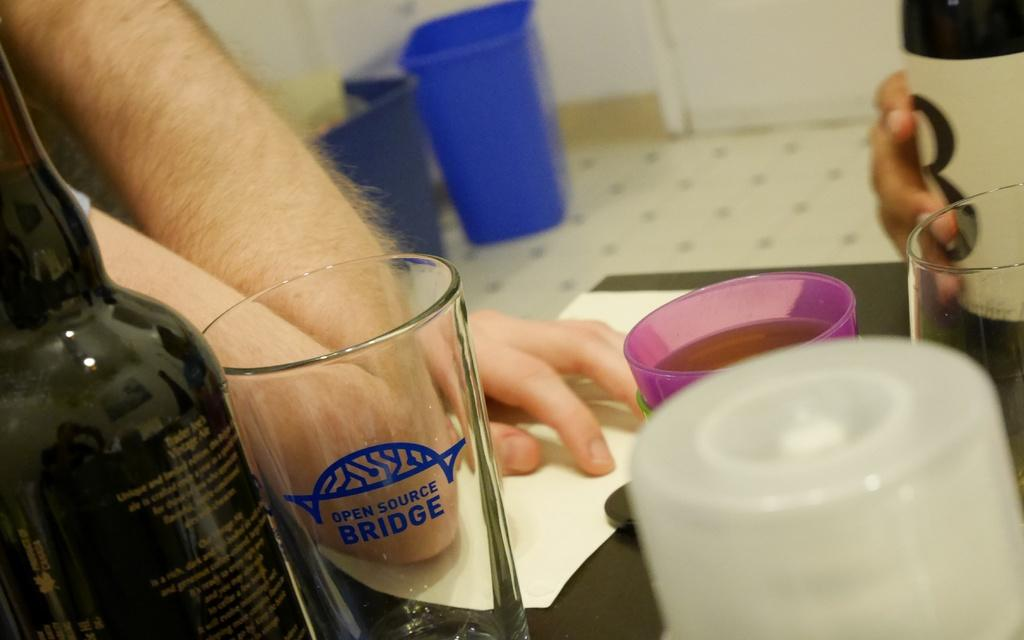<image>
Write a terse but informative summary of the picture. a cup that says bridge on the front 